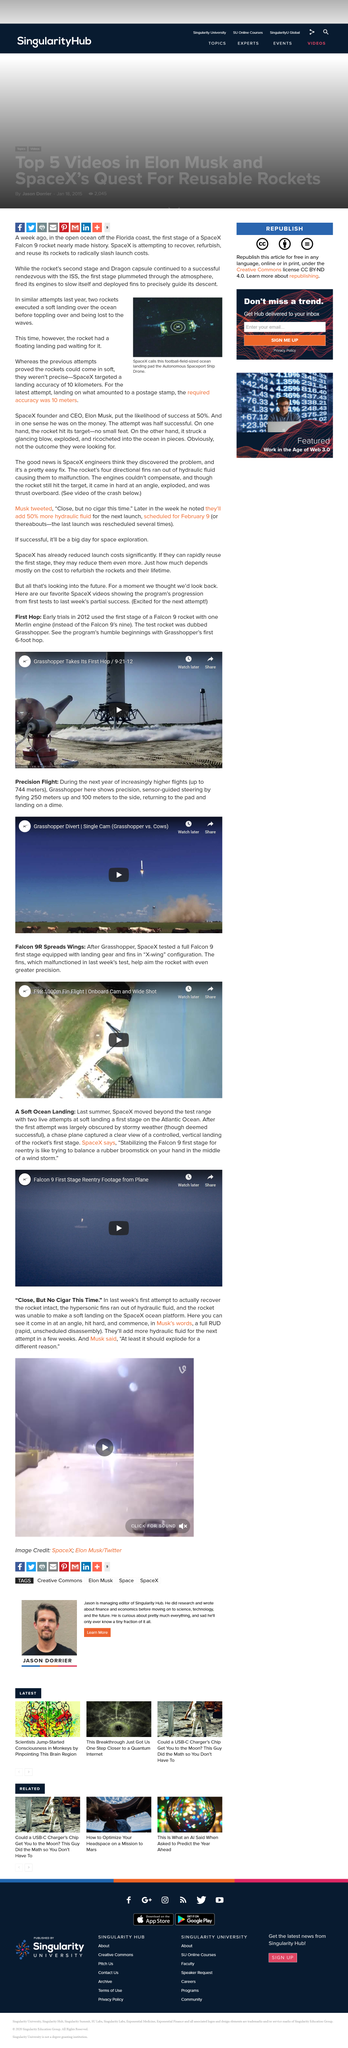Specify some key components in this picture. Last year, during similar attempts, two rockets executed a soft landing in the ocean before toppling over and being lost to the waves. The above image represents SpaceX's Autonomous Spaceport Ship Drone, a futuristic vessel designed for autonomous transportation in space. SpaceX's Autonomous Spaceport Ship Drone is a football-field-sized ocean landing pad that serves as a platform for our reusable rockets to land safely and efficiently. 